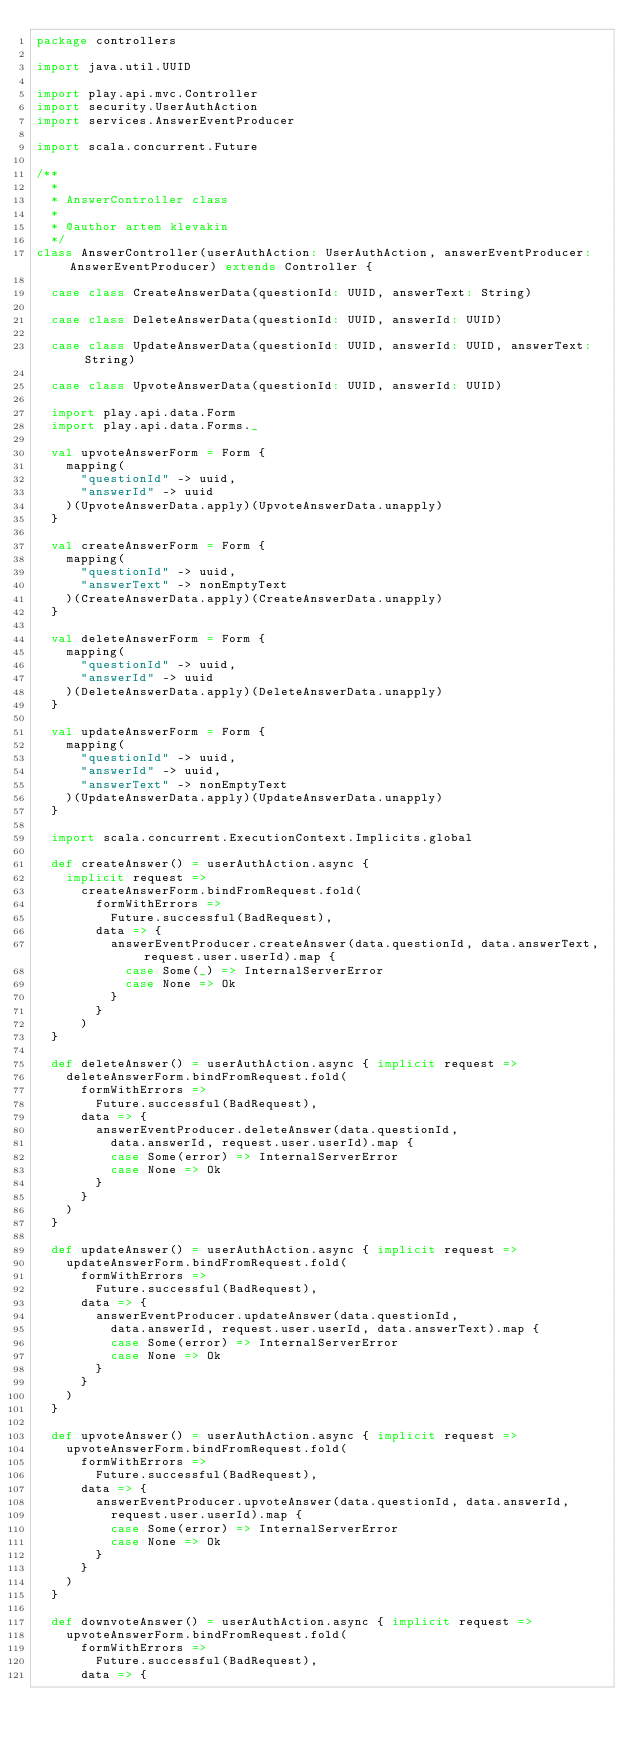Convert code to text. <code><loc_0><loc_0><loc_500><loc_500><_Scala_>package controllers

import java.util.UUID

import play.api.mvc.Controller
import security.UserAuthAction
import services.AnswerEventProducer

import scala.concurrent.Future

/**
  *
  * AnswerController class
  *
  * @author artem klevakin
  */
class AnswerController(userAuthAction: UserAuthAction, answerEventProducer: AnswerEventProducer) extends Controller {

  case class CreateAnswerData(questionId: UUID, answerText: String)

  case class DeleteAnswerData(questionId: UUID, answerId: UUID)

  case class UpdateAnswerData(questionId: UUID, answerId: UUID, answerText: String)

  case class UpvoteAnswerData(questionId: UUID, answerId: UUID)

  import play.api.data.Form
  import play.api.data.Forms._

  val upvoteAnswerForm = Form {
    mapping(
      "questionId" -> uuid,
      "answerId" -> uuid
    )(UpvoteAnswerData.apply)(UpvoteAnswerData.unapply)
  }

  val createAnswerForm = Form {
    mapping(
      "questionId" -> uuid,
      "answerText" -> nonEmptyText
    )(CreateAnswerData.apply)(CreateAnswerData.unapply)
  }

  val deleteAnswerForm = Form {
    mapping(
      "questionId" -> uuid,
      "answerId" -> uuid
    )(DeleteAnswerData.apply)(DeleteAnswerData.unapply)
  }

  val updateAnswerForm = Form {
    mapping(
      "questionId" -> uuid,
      "answerId" -> uuid,
      "answerText" -> nonEmptyText
    )(UpdateAnswerData.apply)(UpdateAnswerData.unapply)
  }

  import scala.concurrent.ExecutionContext.Implicits.global

  def createAnswer() = userAuthAction.async {
    implicit request =>
      createAnswerForm.bindFromRequest.fold(
        formWithErrors =>
          Future.successful(BadRequest),
        data => {
          answerEventProducer.createAnswer(data.questionId, data.answerText, request.user.userId).map {
            case Some(_) => InternalServerError
            case None => Ok
          }
        }
      )
  }

  def deleteAnswer() = userAuthAction.async { implicit request =>
    deleteAnswerForm.bindFromRequest.fold(
      formWithErrors =>
        Future.successful(BadRequest),
      data => {
        answerEventProducer.deleteAnswer(data.questionId,
          data.answerId, request.user.userId).map {
          case Some(error) => InternalServerError
          case None => Ok
        }
      }
    )
  }

  def updateAnswer() = userAuthAction.async { implicit request =>
    updateAnswerForm.bindFromRequest.fold(
      formWithErrors =>
        Future.successful(BadRequest),
      data => {
        answerEventProducer.updateAnswer(data.questionId,
          data.answerId, request.user.userId, data.answerText).map {
          case Some(error) => InternalServerError
          case None => Ok
        }
      }
    )
  }

  def upvoteAnswer() = userAuthAction.async { implicit request =>
    upvoteAnswerForm.bindFromRequest.fold(
      formWithErrors =>
        Future.successful(BadRequest),
      data => {
        answerEventProducer.upvoteAnswer(data.questionId, data.answerId,
          request.user.userId).map {
          case Some(error) => InternalServerError
          case None => Ok
        }
      }
    )
  }

  def downvoteAnswer() = userAuthAction.async { implicit request =>
    upvoteAnswerForm.bindFromRequest.fold(
      formWithErrors =>
        Future.successful(BadRequest),
      data => {</code> 